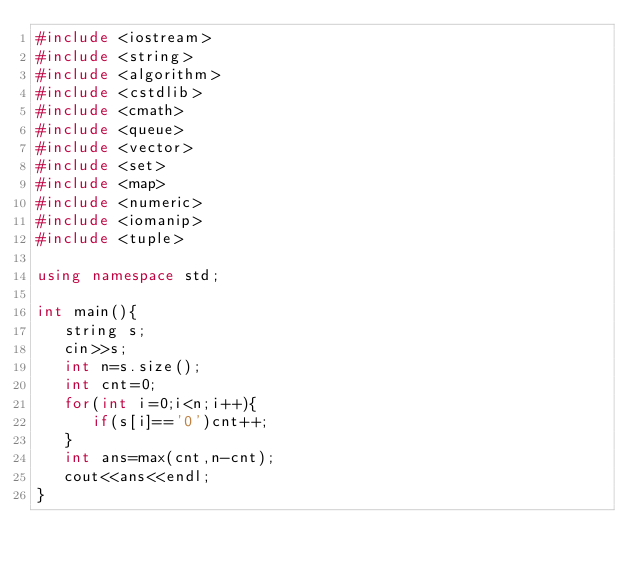Convert code to text. <code><loc_0><loc_0><loc_500><loc_500><_C++_>#include <iostream>
#include <string>
#include <algorithm>
#include <cstdlib>
#include <cmath>
#include <queue>
#include <vector>
#include <set>
#include <map>
#include <numeric>
#include <iomanip>
#include <tuple>

using namespace std;

int main(){
   string s;
   cin>>s;
   int n=s.size();
   int cnt=0;
   for(int i=0;i<n;i++){
      if(s[i]=='0')cnt++;
   }
   int ans=max(cnt,n-cnt);
   cout<<ans<<endl;
}

   
</code> 